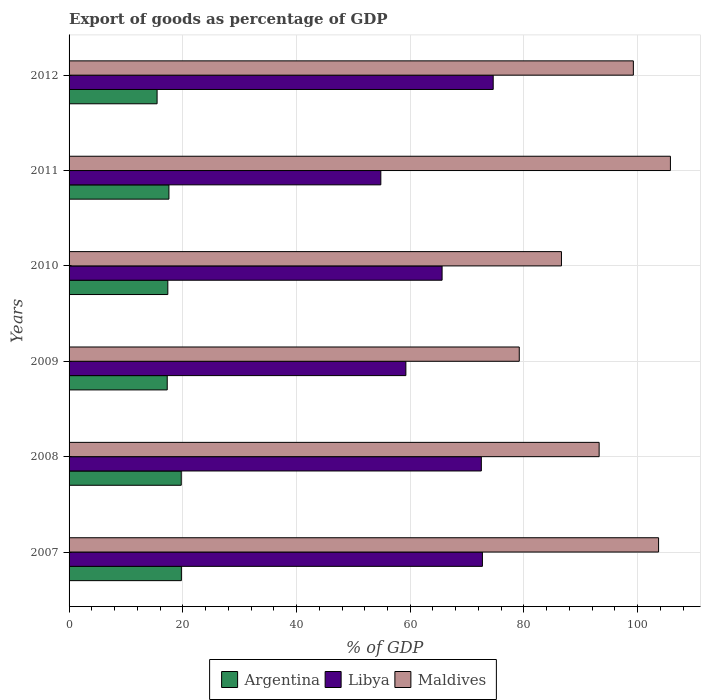How many different coloured bars are there?
Your answer should be very brief. 3. How many groups of bars are there?
Provide a succinct answer. 6. Are the number of bars per tick equal to the number of legend labels?
Keep it short and to the point. Yes. How many bars are there on the 5th tick from the top?
Your response must be concise. 3. In how many cases, is the number of bars for a given year not equal to the number of legend labels?
Your answer should be very brief. 0. What is the export of goods as percentage of GDP in Libya in 2010?
Your answer should be compact. 65.6. Across all years, what is the maximum export of goods as percentage of GDP in Argentina?
Make the answer very short. 19.75. Across all years, what is the minimum export of goods as percentage of GDP in Libya?
Provide a short and direct response. 54.83. In which year was the export of goods as percentage of GDP in Maldives maximum?
Your answer should be compact. 2011. What is the total export of goods as percentage of GDP in Libya in the graph?
Make the answer very short. 399.47. What is the difference between the export of goods as percentage of GDP in Argentina in 2008 and that in 2011?
Offer a very short reply. 2.17. What is the difference between the export of goods as percentage of GDP in Maldives in 2010 and the export of goods as percentage of GDP in Argentina in 2009?
Ensure brevity in your answer.  69.33. What is the average export of goods as percentage of GDP in Libya per year?
Your answer should be compact. 66.58. In the year 2008, what is the difference between the export of goods as percentage of GDP in Argentina and export of goods as percentage of GDP in Maldives?
Make the answer very short. -73.5. In how many years, is the export of goods as percentage of GDP in Libya greater than 84 %?
Your answer should be compact. 0. What is the ratio of the export of goods as percentage of GDP in Argentina in 2007 to that in 2008?
Your response must be concise. 1. What is the difference between the highest and the second highest export of goods as percentage of GDP in Libya?
Ensure brevity in your answer.  1.89. What is the difference between the highest and the lowest export of goods as percentage of GDP in Argentina?
Your answer should be very brief. 4.27. In how many years, is the export of goods as percentage of GDP in Libya greater than the average export of goods as percentage of GDP in Libya taken over all years?
Offer a terse response. 3. Is the sum of the export of goods as percentage of GDP in Argentina in 2009 and 2010 greater than the maximum export of goods as percentage of GDP in Maldives across all years?
Your answer should be very brief. No. What does the 3rd bar from the top in 2008 represents?
Keep it short and to the point. Argentina. Is it the case that in every year, the sum of the export of goods as percentage of GDP in Argentina and export of goods as percentage of GDP in Maldives is greater than the export of goods as percentage of GDP in Libya?
Make the answer very short. Yes. How many bars are there?
Ensure brevity in your answer.  18. Are all the bars in the graph horizontal?
Offer a terse response. Yes. How many years are there in the graph?
Offer a terse response. 6. Where does the legend appear in the graph?
Provide a short and direct response. Bottom center. How many legend labels are there?
Make the answer very short. 3. What is the title of the graph?
Give a very brief answer. Export of goods as percentage of GDP. Does "South Sudan" appear as one of the legend labels in the graph?
Keep it short and to the point. No. What is the label or title of the X-axis?
Provide a succinct answer. % of GDP. What is the label or title of the Y-axis?
Provide a short and direct response. Years. What is the % of GDP of Argentina in 2007?
Offer a terse response. 19.75. What is the % of GDP of Libya in 2007?
Make the answer very short. 72.7. What is the % of GDP in Maldives in 2007?
Give a very brief answer. 103.68. What is the % of GDP in Argentina in 2008?
Provide a succinct answer. 19.73. What is the % of GDP in Libya in 2008?
Offer a very short reply. 72.51. What is the % of GDP in Maldives in 2008?
Keep it short and to the point. 93.23. What is the % of GDP of Argentina in 2009?
Offer a very short reply. 17.27. What is the % of GDP of Libya in 2009?
Make the answer very short. 59.24. What is the % of GDP of Maldives in 2009?
Your response must be concise. 79.18. What is the % of GDP in Argentina in 2010?
Give a very brief answer. 17.37. What is the % of GDP in Libya in 2010?
Make the answer very short. 65.6. What is the % of GDP of Maldives in 2010?
Keep it short and to the point. 86.6. What is the % of GDP in Argentina in 2011?
Provide a short and direct response. 17.56. What is the % of GDP in Libya in 2011?
Your answer should be very brief. 54.83. What is the % of GDP in Maldives in 2011?
Offer a terse response. 105.76. What is the % of GDP in Argentina in 2012?
Offer a terse response. 15.48. What is the % of GDP of Libya in 2012?
Give a very brief answer. 74.59. What is the % of GDP of Maldives in 2012?
Ensure brevity in your answer.  99.24. Across all years, what is the maximum % of GDP in Argentina?
Your answer should be compact. 19.75. Across all years, what is the maximum % of GDP of Libya?
Ensure brevity in your answer.  74.59. Across all years, what is the maximum % of GDP of Maldives?
Ensure brevity in your answer.  105.76. Across all years, what is the minimum % of GDP in Argentina?
Keep it short and to the point. 15.48. Across all years, what is the minimum % of GDP in Libya?
Your answer should be very brief. 54.83. Across all years, what is the minimum % of GDP of Maldives?
Your answer should be very brief. 79.18. What is the total % of GDP of Argentina in the graph?
Your answer should be very brief. 107.16. What is the total % of GDP of Libya in the graph?
Ensure brevity in your answer.  399.47. What is the total % of GDP of Maldives in the graph?
Provide a short and direct response. 567.69. What is the difference between the % of GDP in Argentina in 2007 and that in 2008?
Offer a terse response. 0.02. What is the difference between the % of GDP of Libya in 2007 and that in 2008?
Your response must be concise. 0.19. What is the difference between the % of GDP of Maldives in 2007 and that in 2008?
Provide a short and direct response. 10.45. What is the difference between the % of GDP of Argentina in 2007 and that in 2009?
Keep it short and to the point. 2.49. What is the difference between the % of GDP of Libya in 2007 and that in 2009?
Provide a succinct answer. 13.46. What is the difference between the % of GDP in Maldives in 2007 and that in 2009?
Your answer should be very brief. 24.5. What is the difference between the % of GDP of Argentina in 2007 and that in 2010?
Your answer should be compact. 2.39. What is the difference between the % of GDP in Libya in 2007 and that in 2010?
Offer a terse response. 7.09. What is the difference between the % of GDP of Maldives in 2007 and that in 2010?
Keep it short and to the point. 17.08. What is the difference between the % of GDP in Argentina in 2007 and that in 2011?
Make the answer very short. 2.19. What is the difference between the % of GDP of Libya in 2007 and that in 2011?
Make the answer very short. 17.87. What is the difference between the % of GDP of Maldives in 2007 and that in 2011?
Give a very brief answer. -2.08. What is the difference between the % of GDP in Argentina in 2007 and that in 2012?
Your answer should be very brief. 4.27. What is the difference between the % of GDP in Libya in 2007 and that in 2012?
Your answer should be compact. -1.89. What is the difference between the % of GDP of Maldives in 2007 and that in 2012?
Your response must be concise. 4.43. What is the difference between the % of GDP in Argentina in 2008 and that in 2009?
Provide a short and direct response. 2.46. What is the difference between the % of GDP in Libya in 2008 and that in 2009?
Give a very brief answer. 13.27. What is the difference between the % of GDP of Maldives in 2008 and that in 2009?
Your answer should be compact. 14.05. What is the difference between the % of GDP in Argentina in 2008 and that in 2010?
Offer a very short reply. 2.36. What is the difference between the % of GDP in Libya in 2008 and that in 2010?
Ensure brevity in your answer.  6.9. What is the difference between the % of GDP in Maldives in 2008 and that in 2010?
Ensure brevity in your answer.  6.63. What is the difference between the % of GDP in Argentina in 2008 and that in 2011?
Your response must be concise. 2.17. What is the difference between the % of GDP in Libya in 2008 and that in 2011?
Make the answer very short. 17.68. What is the difference between the % of GDP in Maldives in 2008 and that in 2011?
Offer a very short reply. -12.54. What is the difference between the % of GDP in Argentina in 2008 and that in 2012?
Give a very brief answer. 4.25. What is the difference between the % of GDP of Libya in 2008 and that in 2012?
Provide a succinct answer. -2.09. What is the difference between the % of GDP of Maldives in 2008 and that in 2012?
Your response must be concise. -6.02. What is the difference between the % of GDP in Argentina in 2009 and that in 2010?
Keep it short and to the point. -0.1. What is the difference between the % of GDP in Libya in 2009 and that in 2010?
Your response must be concise. -6.37. What is the difference between the % of GDP of Maldives in 2009 and that in 2010?
Your response must be concise. -7.42. What is the difference between the % of GDP of Argentina in 2009 and that in 2011?
Your answer should be compact. -0.3. What is the difference between the % of GDP of Libya in 2009 and that in 2011?
Offer a very short reply. 4.41. What is the difference between the % of GDP of Maldives in 2009 and that in 2011?
Your answer should be compact. -26.59. What is the difference between the % of GDP of Argentina in 2009 and that in 2012?
Your answer should be very brief. 1.78. What is the difference between the % of GDP of Libya in 2009 and that in 2012?
Provide a succinct answer. -15.36. What is the difference between the % of GDP in Maldives in 2009 and that in 2012?
Give a very brief answer. -20.07. What is the difference between the % of GDP of Argentina in 2010 and that in 2011?
Give a very brief answer. -0.2. What is the difference between the % of GDP in Libya in 2010 and that in 2011?
Offer a terse response. 10.78. What is the difference between the % of GDP of Maldives in 2010 and that in 2011?
Your answer should be compact. -19.16. What is the difference between the % of GDP of Argentina in 2010 and that in 2012?
Provide a succinct answer. 1.89. What is the difference between the % of GDP of Libya in 2010 and that in 2012?
Ensure brevity in your answer.  -8.99. What is the difference between the % of GDP of Maldives in 2010 and that in 2012?
Your response must be concise. -12.65. What is the difference between the % of GDP in Argentina in 2011 and that in 2012?
Make the answer very short. 2.08. What is the difference between the % of GDP of Libya in 2011 and that in 2012?
Ensure brevity in your answer.  -19.76. What is the difference between the % of GDP of Maldives in 2011 and that in 2012?
Your answer should be very brief. 6.52. What is the difference between the % of GDP in Argentina in 2007 and the % of GDP in Libya in 2008?
Your answer should be compact. -52.75. What is the difference between the % of GDP of Argentina in 2007 and the % of GDP of Maldives in 2008?
Give a very brief answer. -73.47. What is the difference between the % of GDP in Libya in 2007 and the % of GDP in Maldives in 2008?
Give a very brief answer. -20.53. What is the difference between the % of GDP of Argentina in 2007 and the % of GDP of Libya in 2009?
Offer a very short reply. -39.48. What is the difference between the % of GDP in Argentina in 2007 and the % of GDP in Maldives in 2009?
Offer a terse response. -59.42. What is the difference between the % of GDP in Libya in 2007 and the % of GDP in Maldives in 2009?
Offer a terse response. -6.48. What is the difference between the % of GDP in Argentina in 2007 and the % of GDP in Libya in 2010?
Make the answer very short. -45.85. What is the difference between the % of GDP of Argentina in 2007 and the % of GDP of Maldives in 2010?
Your response must be concise. -66.85. What is the difference between the % of GDP in Libya in 2007 and the % of GDP in Maldives in 2010?
Ensure brevity in your answer.  -13.9. What is the difference between the % of GDP of Argentina in 2007 and the % of GDP of Libya in 2011?
Your answer should be very brief. -35.08. What is the difference between the % of GDP in Argentina in 2007 and the % of GDP in Maldives in 2011?
Your answer should be very brief. -86.01. What is the difference between the % of GDP of Libya in 2007 and the % of GDP of Maldives in 2011?
Your response must be concise. -33.06. What is the difference between the % of GDP of Argentina in 2007 and the % of GDP of Libya in 2012?
Keep it short and to the point. -54.84. What is the difference between the % of GDP of Argentina in 2007 and the % of GDP of Maldives in 2012?
Offer a very short reply. -79.49. What is the difference between the % of GDP in Libya in 2007 and the % of GDP in Maldives in 2012?
Offer a terse response. -26.55. What is the difference between the % of GDP of Argentina in 2008 and the % of GDP of Libya in 2009?
Provide a short and direct response. -39.51. What is the difference between the % of GDP of Argentina in 2008 and the % of GDP of Maldives in 2009?
Offer a very short reply. -59.45. What is the difference between the % of GDP of Libya in 2008 and the % of GDP of Maldives in 2009?
Offer a terse response. -6.67. What is the difference between the % of GDP of Argentina in 2008 and the % of GDP of Libya in 2010?
Offer a terse response. -45.88. What is the difference between the % of GDP in Argentina in 2008 and the % of GDP in Maldives in 2010?
Give a very brief answer. -66.87. What is the difference between the % of GDP in Libya in 2008 and the % of GDP in Maldives in 2010?
Give a very brief answer. -14.09. What is the difference between the % of GDP of Argentina in 2008 and the % of GDP of Libya in 2011?
Your answer should be compact. -35.1. What is the difference between the % of GDP of Argentina in 2008 and the % of GDP of Maldives in 2011?
Give a very brief answer. -86.03. What is the difference between the % of GDP in Libya in 2008 and the % of GDP in Maldives in 2011?
Provide a succinct answer. -33.26. What is the difference between the % of GDP of Argentina in 2008 and the % of GDP of Libya in 2012?
Offer a terse response. -54.86. What is the difference between the % of GDP of Argentina in 2008 and the % of GDP of Maldives in 2012?
Provide a short and direct response. -79.52. What is the difference between the % of GDP in Libya in 2008 and the % of GDP in Maldives in 2012?
Make the answer very short. -26.74. What is the difference between the % of GDP in Argentina in 2009 and the % of GDP in Libya in 2010?
Your answer should be compact. -48.34. What is the difference between the % of GDP in Argentina in 2009 and the % of GDP in Maldives in 2010?
Give a very brief answer. -69.33. What is the difference between the % of GDP in Libya in 2009 and the % of GDP in Maldives in 2010?
Give a very brief answer. -27.36. What is the difference between the % of GDP in Argentina in 2009 and the % of GDP in Libya in 2011?
Offer a very short reply. -37.56. What is the difference between the % of GDP of Argentina in 2009 and the % of GDP of Maldives in 2011?
Your answer should be very brief. -88.5. What is the difference between the % of GDP in Libya in 2009 and the % of GDP in Maldives in 2011?
Make the answer very short. -46.53. What is the difference between the % of GDP in Argentina in 2009 and the % of GDP in Libya in 2012?
Offer a terse response. -57.33. What is the difference between the % of GDP in Argentina in 2009 and the % of GDP in Maldives in 2012?
Keep it short and to the point. -81.98. What is the difference between the % of GDP in Libya in 2009 and the % of GDP in Maldives in 2012?
Your answer should be compact. -40.01. What is the difference between the % of GDP of Argentina in 2010 and the % of GDP of Libya in 2011?
Offer a terse response. -37.46. What is the difference between the % of GDP of Argentina in 2010 and the % of GDP of Maldives in 2011?
Keep it short and to the point. -88.4. What is the difference between the % of GDP of Libya in 2010 and the % of GDP of Maldives in 2011?
Keep it short and to the point. -40.16. What is the difference between the % of GDP in Argentina in 2010 and the % of GDP in Libya in 2012?
Give a very brief answer. -57.23. What is the difference between the % of GDP of Argentina in 2010 and the % of GDP of Maldives in 2012?
Your response must be concise. -81.88. What is the difference between the % of GDP in Libya in 2010 and the % of GDP in Maldives in 2012?
Your answer should be compact. -33.64. What is the difference between the % of GDP in Argentina in 2011 and the % of GDP in Libya in 2012?
Give a very brief answer. -57.03. What is the difference between the % of GDP of Argentina in 2011 and the % of GDP of Maldives in 2012?
Make the answer very short. -81.68. What is the difference between the % of GDP of Libya in 2011 and the % of GDP of Maldives in 2012?
Your answer should be compact. -44.41. What is the average % of GDP of Argentina per year?
Keep it short and to the point. 17.86. What is the average % of GDP in Libya per year?
Your answer should be very brief. 66.58. What is the average % of GDP of Maldives per year?
Provide a succinct answer. 94.61. In the year 2007, what is the difference between the % of GDP of Argentina and % of GDP of Libya?
Your response must be concise. -52.95. In the year 2007, what is the difference between the % of GDP in Argentina and % of GDP in Maldives?
Offer a terse response. -83.93. In the year 2007, what is the difference between the % of GDP in Libya and % of GDP in Maldives?
Your response must be concise. -30.98. In the year 2008, what is the difference between the % of GDP of Argentina and % of GDP of Libya?
Offer a very short reply. -52.78. In the year 2008, what is the difference between the % of GDP of Argentina and % of GDP of Maldives?
Your answer should be compact. -73.5. In the year 2008, what is the difference between the % of GDP in Libya and % of GDP in Maldives?
Your answer should be compact. -20.72. In the year 2009, what is the difference between the % of GDP of Argentina and % of GDP of Libya?
Ensure brevity in your answer.  -41.97. In the year 2009, what is the difference between the % of GDP in Argentina and % of GDP in Maldives?
Make the answer very short. -61.91. In the year 2009, what is the difference between the % of GDP of Libya and % of GDP of Maldives?
Keep it short and to the point. -19.94. In the year 2010, what is the difference between the % of GDP of Argentina and % of GDP of Libya?
Make the answer very short. -48.24. In the year 2010, what is the difference between the % of GDP of Argentina and % of GDP of Maldives?
Offer a very short reply. -69.23. In the year 2010, what is the difference between the % of GDP in Libya and % of GDP in Maldives?
Your response must be concise. -20.99. In the year 2011, what is the difference between the % of GDP of Argentina and % of GDP of Libya?
Make the answer very short. -37.27. In the year 2011, what is the difference between the % of GDP of Argentina and % of GDP of Maldives?
Provide a short and direct response. -88.2. In the year 2011, what is the difference between the % of GDP of Libya and % of GDP of Maldives?
Your answer should be compact. -50.93. In the year 2012, what is the difference between the % of GDP in Argentina and % of GDP in Libya?
Provide a short and direct response. -59.11. In the year 2012, what is the difference between the % of GDP of Argentina and % of GDP of Maldives?
Your response must be concise. -83.76. In the year 2012, what is the difference between the % of GDP in Libya and % of GDP in Maldives?
Your answer should be very brief. -24.65. What is the ratio of the % of GDP in Argentina in 2007 to that in 2008?
Ensure brevity in your answer.  1. What is the ratio of the % of GDP of Libya in 2007 to that in 2008?
Provide a short and direct response. 1. What is the ratio of the % of GDP in Maldives in 2007 to that in 2008?
Give a very brief answer. 1.11. What is the ratio of the % of GDP in Argentina in 2007 to that in 2009?
Keep it short and to the point. 1.14. What is the ratio of the % of GDP in Libya in 2007 to that in 2009?
Ensure brevity in your answer.  1.23. What is the ratio of the % of GDP in Maldives in 2007 to that in 2009?
Your response must be concise. 1.31. What is the ratio of the % of GDP of Argentina in 2007 to that in 2010?
Provide a succinct answer. 1.14. What is the ratio of the % of GDP of Libya in 2007 to that in 2010?
Provide a succinct answer. 1.11. What is the ratio of the % of GDP of Maldives in 2007 to that in 2010?
Offer a very short reply. 1.2. What is the ratio of the % of GDP in Argentina in 2007 to that in 2011?
Your response must be concise. 1.12. What is the ratio of the % of GDP in Libya in 2007 to that in 2011?
Your answer should be compact. 1.33. What is the ratio of the % of GDP in Maldives in 2007 to that in 2011?
Give a very brief answer. 0.98. What is the ratio of the % of GDP of Argentina in 2007 to that in 2012?
Provide a succinct answer. 1.28. What is the ratio of the % of GDP in Libya in 2007 to that in 2012?
Make the answer very short. 0.97. What is the ratio of the % of GDP of Maldives in 2007 to that in 2012?
Offer a very short reply. 1.04. What is the ratio of the % of GDP in Argentina in 2008 to that in 2009?
Ensure brevity in your answer.  1.14. What is the ratio of the % of GDP of Libya in 2008 to that in 2009?
Your response must be concise. 1.22. What is the ratio of the % of GDP in Maldives in 2008 to that in 2009?
Provide a short and direct response. 1.18. What is the ratio of the % of GDP in Argentina in 2008 to that in 2010?
Offer a terse response. 1.14. What is the ratio of the % of GDP of Libya in 2008 to that in 2010?
Provide a short and direct response. 1.11. What is the ratio of the % of GDP in Maldives in 2008 to that in 2010?
Your answer should be very brief. 1.08. What is the ratio of the % of GDP of Argentina in 2008 to that in 2011?
Your response must be concise. 1.12. What is the ratio of the % of GDP in Libya in 2008 to that in 2011?
Make the answer very short. 1.32. What is the ratio of the % of GDP in Maldives in 2008 to that in 2011?
Offer a terse response. 0.88. What is the ratio of the % of GDP of Argentina in 2008 to that in 2012?
Provide a succinct answer. 1.27. What is the ratio of the % of GDP in Libya in 2008 to that in 2012?
Give a very brief answer. 0.97. What is the ratio of the % of GDP in Maldives in 2008 to that in 2012?
Make the answer very short. 0.94. What is the ratio of the % of GDP in Libya in 2009 to that in 2010?
Ensure brevity in your answer.  0.9. What is the ratio of the % of GDP in Maldives in 2009 to that in 2010?
Keep it short and to the point. 0.91. What is the ratio of the % of GDP of Argentina in 2009 to that in 2011?
Your answer should be compact. 0.98. What is the ratio of the % of GDP in Libya in 2009 to that in 2011?
Make the answer very short. 1.08. What is the ratio of the % of GDP of Maldives in 2009 to that in 2011?
Your response must be concise. 0.75. What is the ratio of the % of GDP in Argentina in 2009 to that in 2012?
Keep it short and to the point. 1.12. What is the ratio of the % of GDP in Libya in 2009 to that in 2012?
Keep it short and to the point. 0.79. What is the ratio of the % of GDP of Maldives in 2009 to that in 2012?
Your response must be concise. 0.8. What is the ratio of the % of GDP in Libya in 2010 to that in 2011?
Ensure brevity in your answer.  1.2. What is the ratio of the % of GDP in Maldives in 2010 to that in 2011?
Keep it short and to the point. 0.82. What is the ratio of the % of GDP in Argentina in 2010 to that in 2012?
Provide a short and direct response. 1.12. What is the ratio of the % of GDP of Libya in 2010 to that in 2012?
Your response must be concise. 0.88. What is the ratio of the % of GDP in Maldives in 2010 to that in 2012?
Make the answer very short. 0.87. What is the ratio of the % of GDP in Argentina in 2011 to that in 2012?
Your answer should be compact. 1.13. What is the ratio of the % of GDP in Libya in 2011 to that in 2012?
Provide a short and direct response. 0.73. What is the ratio of the % of GDP of Maldives in 2011 to that in 2012?
Provide a succinct answer. 1.07. What is the difference between the highest and the second highest % of GDP of Argentina?
Make the answer very short. 0.02. What is the difference between the highest and the second highest % of GDP in Libya?
Provide a short and direct response. 1.89. What is the difference between the highest and the second highest % of GDP of Maldives?
Your answer should be compact. 2.08. What is the difference between the highest and the lowest % of GDP in Argentina?
Provide a short and direct response. 4.27. What is the difference between the highest and the lowest % of GDP in Libya?
Your response must be concise. 19.76. What is the difference between the highest and the lowest % of GDP of Maldives?
Your answer should be compact. 26.59. 